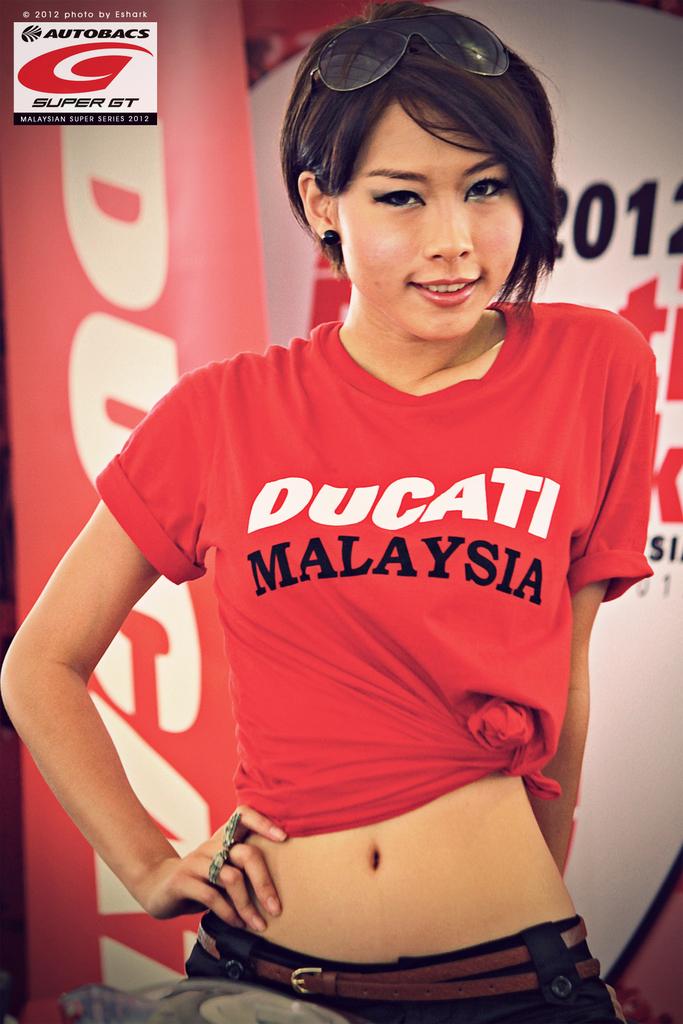What country is this girl most likely from?
Provide a succinct answer. Malaysia. 